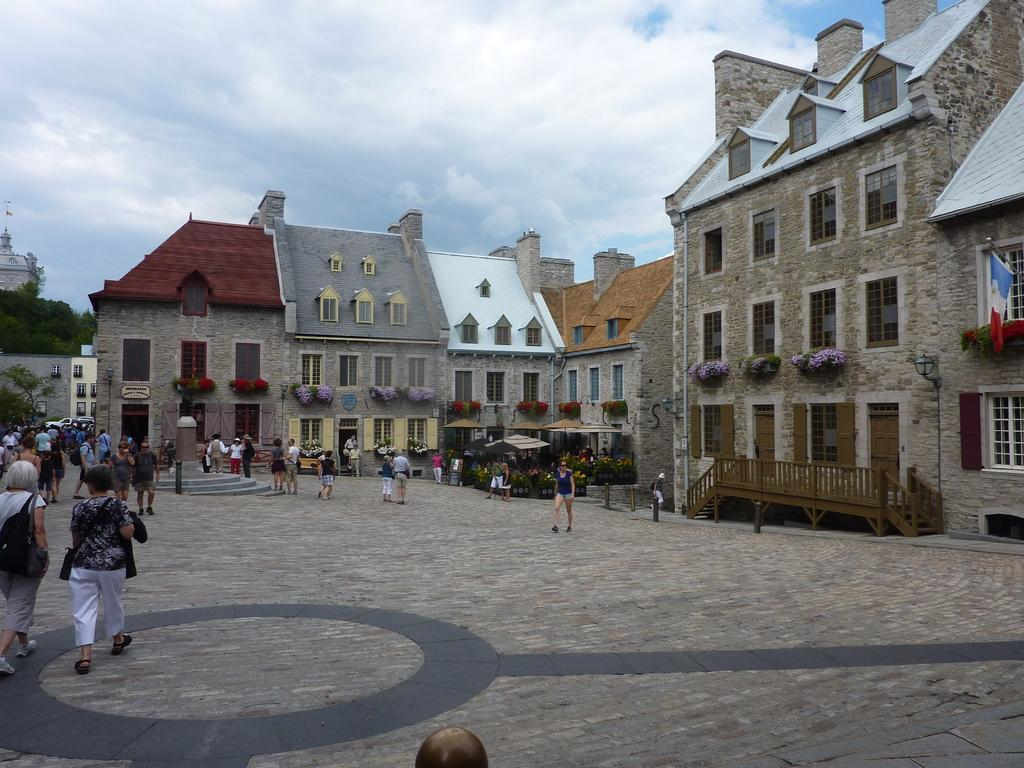What is the weather like in the image? The sky in the image is cloudy. What structures can be seen in the image? There are buildings in the image. What are the people in the image doing? There are people walking in the image. What type of vegetation is present in the image? Trees are present in the image. Where is the flag located in the image? The flag is on a building in the image. Can you tell me how many dolls the boy is carrying in the image? There is no boy or doll present in the image. 